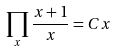<formula> <loc_0><loc_0><loc_500><loc_500>\prod _ { x } \frac { x + 1 } { x } = C x</formula> 